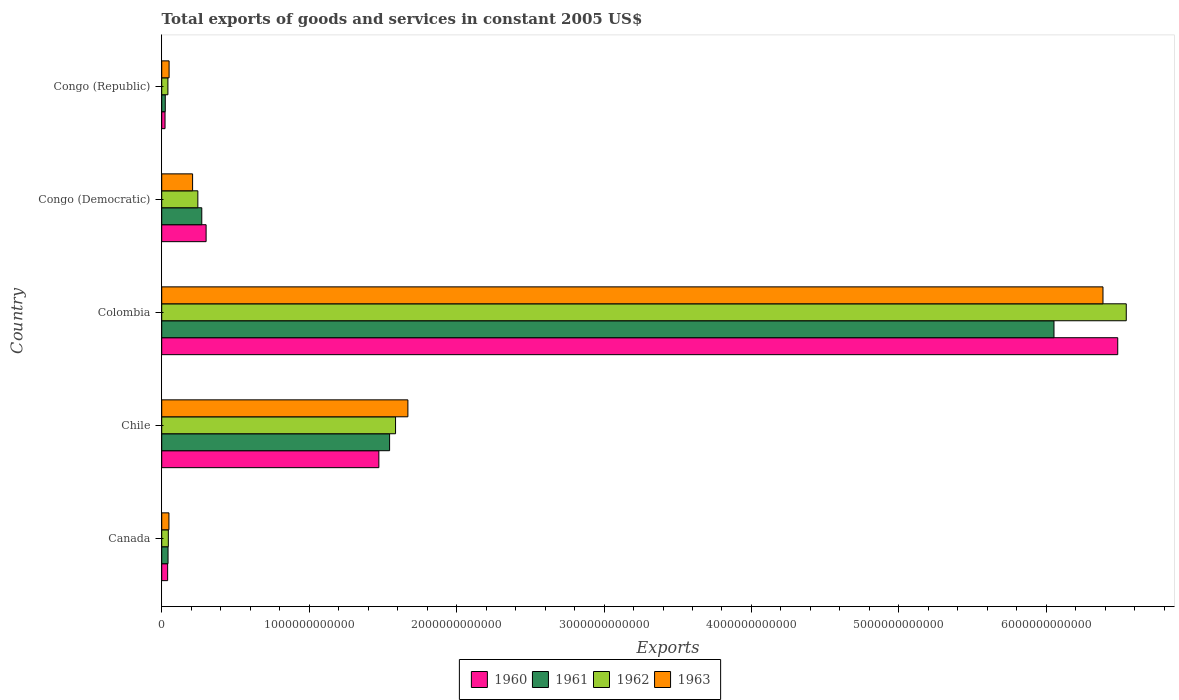Are the number of bars per tick equal to the number of legend labels?
Your answer should be compact. Yes. How many bars are there on the 3rd tick from the top?
Provide a short and direct response. 4. How many bars are there on the 4th tick from the bottom?
Keep it short and to the point. 4. What is the total exports of goods and services in 1963 in Chile?
Your answer should be very brief. 1.67e+12. Across all countries, what is the maximum total exports of goods and services in 1960?
Offer a terse response. 6.48e+12. Across all countries, what is the minimum total exports of goods and services in 1962?
Keep it short and to the point. 4.20e+1. In which country was the total exports of goods and services in 1963 maximum?
Ensure brevity in your answer.  Colombia. In which country was the total exports of goods and services in 1962 minimum?
Ensure brevity in your answer.  Congo (Republic). What is the total total exports of goods and services in 1963 in the graph?
Offer a very short reply. 8.36e+12. What is the difference between the total exports of goods and services in 1960 in Canada and that in Congo (Democratic)?
Give a very brief answer. -2.61e+11. What is the difference between the total exports of goods and services in 1960 in Congo (Democratic) and the total exports of goods and services in 1962 in Congo (Republic)?
Provide a short and direct response. 2.59e+11. What is the average total exports of goods and services in 1962 per country?
Provide a short and direct response. 1.69e+12. What is the difference between the total exports of goods and services in 1962 and total exports of goods and services in 1961 in Chile?
Provide a short and direct response. 4.03e+1. What is the ratio of the total exports of goods and services in 1961 in Colombia to that in Congo (Democratic)?
Give a very brief answer. 22.27. Is the difference between the total exports of goods and services in 1962 in Canada and Chile greater than the difference between the total exports of goods and services in 1961 in Canada and Chile?
Make the answer very short. No. What is the difference between the highest and the second highest total exports of goods and services in 1962?
Provide a short and direct response. 4.96e+12. What is the difference between the highest and the lowest total exports of goods and services in 1962?
Your answer should be very brief. 6.50e+12. Is the sum of the total exports of goods and services in 1960 in Canada and Congo (Democratic) greater than the maximum total exports of goods and services in 1962 across all countries?
Ensure brevity in your answer.  No. What does the 3rd bar from the top in Congo (Republic) represents?
Provide a short and direct response. 1961. How many bars are there?
Provide a short and direct response. 20. Are all the bars in the graph horizontal?
Provide a short and direct response. Yes. What is the difference between two consecutive major ticks on the X-axis?
Your answer should be compact. 1.00e+12. Are the values on the major ticks of X-axis written in scientific E-notation?
Offer a very short reply. No. Where does the legend appear in the graph?
Your response must be concise. Bottom center. How are the legend labels stacked?
Offer a very short reply. Horizontal. What is the title of the graph?
Ensure brevity in your answer.  Total exports of goods and services in constant 2005 US$. Does "1967" appear as one of the legend labels in the graph?
Your answer should be compact. No. What is the label or title of the X-axis?
Keep it short and to the point. Exports. What is the label or title of the Y-axis?
Your answer should be compact. Country. What is the Exports of 1960 in Canada?
Give a very brief answer. 4.02e+1. What is the Exports of 1961 in Canada?
Offer a very short reply. 4.29e+1. What is the Exports of 1962 in Canada?
Offer a very short reply. 4.49e+1. What is the Exports of 1963 in Canada?
Offer a very short reply. 4.91e+1. What is the Exports in 1960 in Chile?
Provide a succinct answer. 1.47e+12. What is the Exports in 1961 in Chile?
Keep it short and to the point. 1.55e+12. What is the Exports of 1962 in Chile?
Your answer should be very brief. 1.59e+12. What is the Exports in 1963 in Chile?
Give a very brief answer. 1.67e+12. What is the Exports of 1960 in Colombia?
Make the answer very short. 6.48e+12. What is the Exports of 1961 in Colombia?
Make the answer very short. 6.05e+12. What is the Exports of 1962 in Colombia?
Ensure brevity in your answer.  6.54e+12. What is the Exports of 1963 in Colombia?
Offer a very short reply. 6.38e+12. What is the Exports in 1960 in Congo (Democratic)?
Your answer should be very brief. 3.01e+11. What is the Exports of 1961 in Congo (Democratic)?
Your answer should be compact. 2.72e+11. What is the Exports in 1962 in Congo (Democratic)?
Make the answer very short. 2.45e+11. What is the Exports of 1963 in Congo (Democratic)?
Your response must be concise. 2.09e+11. What is the Exports in 1960 in Congo (Republic)?
Provide a short and direct response. 2.25e+1. What is the Exports in 1961 in Congo (Republic)?
Your answer should be compact. 2.42e+1. What is the Exports of 1962 in Congo (Republic)?
Offer a very short reply. 4.20e+1. What is the Exports in 1963 in Congo (Republic)?
Your answer should be compact. 5.01e+1. Across all countries, what is the maximum Exports in 1960?
Your answer should be very brief. 6.48e+12. Across all countries, what is the maximum Exports in 1961?
Offer a terse response. 6.05e+12. Across all countries, what is the maximum Exports of 1962?
Keep it short and to the point. 6.54e+12. Across all countries, what is the maximum Exports of 1963?
Keep it short and to the point. 6.38e+12. Across all countries, what is the minimum Exports in 1960?
Provide a succinct answer. 2.25e+1. Across all countries, what is the minimum Exports of 1961?
Give a very brief answer. 2.42e+1. Across all countries, what is the minimum Exports of 1962?
Your answer should be compact. 4.20e+1. Across all countries, what is the minimum Exports of 1963?
Offer a very short reply. 4.91e+1. What is the total Exports in 1960 in the graph?
Make the answer very short. 8.32e+12. What is the total Exports of 1961 in the graph?
Your answer should be compact. 7.94e+12. What is the total Exports of 1962 in the graph?
Make the answer very short. 8.46e+12. What is the total Exports of 1963 in the graph?
Provide a succinct answer. 8.36e+12. What is the difference between the Exports of 1960 in Canada and that in Chile?
Your response must be concise. -1.43e+12. What is the difference between the Exports of 1961 in Canada and that in Chile?
Provide a short and direct response. -1.50e+12. What is the difference between the Exports in 1962 in Canada and that in Chile?
Your answer should be very brief. -1.54e+12. What is the difference between the Exports in 1963 in Canada and that in Chile?
Make the answer very short. -1.62e+12. What is the difference between the Exports of 1960 in Canada and that in Colombia?
Your answer should be very brief. -6.44e+12. What is the difference between the Exports in 1961 in Canada and that in Colombia?
Provide a succinct answer. -6.01e+12. What is the difference between the Exports of 1962 in Canada and that in Colombia?
Offer a terse response. -6.50e+12. What is the difference between the Exports of 1963 in Canada and that in Colombia?
Offer a terse response. -6.34e+12. What is the difference between the Exports of 1960 in Canada and that in Congo (Democratic)?
Your answer should be very brief. -2.61e+11. What is the difference between the Exports of 1961 in Canada and that in Congo (Democratic)?
Offer a terse response. -2.29e+11. What is the difference between the Exports in 1962 in Canada and that in Congo (Democratic)?
Ensure brevity in your answer.  -2.00e+11. What is the difference between the Exports of 1963 in Canada and that in Congo (Democratic)?
Provide a short and direct response. -1.60e+11. What is the difference between the Exports in 1960 in Canada and that in Congo (Republic)?
Keep it short and to the point. 1.77e+1. What is the difference between the Exports of 1961 in Canada and that in Congo (Republic)?
Provide a succinct answer. 1.87e+1. What is the difference between the Exports of 1962 in Canada and that in Congo (Republic)?
Keep it short and to the point. 2.86e+09. What is the difference between the Exports in 1963 in Canada and that in Congo (Republic)?
Your answer should be compact. -1.07e+09. What is the difference between the Exports in 1960 in Chile and that in Colombia?
Provide a short and direct response. -5.01e+12. What is the difference between the Exports in 1961 in Chile and that in Colombia?
Ensure brevity in your answer.  -4.51e+12. What is the difference between the Exports in 1962 in Chile and that in Colombia?
Provide a short and direct response. -4.96e+12. What is the difference between the Exports in 1963 in Chile and that in Colombia?
Your response must be concise. -4.71e+12. What is the difference between the Exports of 1960 in Chile and that in Congo (Democratic)?
Keep it short and to the point. 1.17e+12. What is the difference between the Exports in 1961 in Chile and that in Congo (Democratic)?
Offer a terse response. 1.27e+12. What is the difference between the Exports in 1962 in Chile and that in Congo (Democratic)?
Offer a terse response. 1.34e+12. What is the difference between the Exports in 1963 in Chile and that in Congo (Democratic)?
Make the answer very short. 1.46e+12. What is the difference between the Exports in 1960 in Chile and that in Congo (Republic)?
Provide a short and direct response. 1.45e+12. What is the difference between the Exports of 1961 in Chile and that in Congo (Republic)?
Provide a short and direct response. 1.52e+12. What is the difference between the Exports of 1962 in Chile and that in Congo (Republic)?
Keep it short and to the point. 1.54e+12. What is the difference between the Exports in 1963 in Chile and that in Congo (Republic)?
Offer a very short reply. 1.62e+12. What is the difference between the Exports of 1960 in Colombia and that in Congo (Democratic)?
Your response must be concise. 6.18e+12. What is the difference between the Exports in 1961 in Colombia and that in Congo (Democratic)?
Offer a terse response. 5.78e+12. What is the difference between the Exports in 1962 in Colombia and that in Congo (Democratic)?
Your response must be concise. 6.30e+12. What is the difference between the Exports of 1963 in Colombia and that in Congo (Democratic)?
Offer a very short reply. 6.17e+12. What is the difference between the Exports of 1960 in Colombia and that in Congo (Republic)?
Offer a terse response. 6.46e+12. What is the difference between the Exports of 1961 in Colombia and that in Congo (Republic)?
Offer a very short reply. 6.03e+12. What is the difference between the Exports in 1962 in Colombia and that in Congo (Republic)?
Ensure brevity in your answer.  6.50e+12. What is the difference between the Exports of 1963 in Colombia and that in Congo (Republic)?
Your answer should be very brief. 6.33e+12. What is the difference between the Exports of 1960 in Congo (Democratic) and that in Congo (Republic)?
Your answer should be compact. 2.79e+11. What is the difference between the Exports of 1961 in Congo (Democratic) and that in Congo (Republic)?
Offer a very short reply. 2.48e+11. What is the difference between the Exports of 1962 in Congo (Democratic) and that in Congo (Republic)?
Provide a short and direct response. 2.03e+11. What is the difference between the Exports of 1963 in Congo (Democratic) and that in Congo (Republic)?
Your response must be concise. 1.59e+11. What is the difference between the Exports of 1960 in Canada and the Exports of 1961 in Chile?
Offer a very short reply. -1.51e+12. What is the difference between the Exports in 1960 in Canada and the Exports in 1962 in Chile?
Make the answer very short. -1.55e+12. What is the difference between the Exports in 1960 in Canada and the Exports in 1963 in Chile?
Your response must be concise. -1.63e+12. What is the difference between the Exports of 1961 in Canada and the Exports of 1962 in Chile?
Your answer should be very brief. -1.54e+12. What is the difference between the Exports in 1961 in Canada and the Exports in 1963 in Chile?
Offer a very short reply. -1.63e+12. What is the difference between the Exports in 1962 in Canada and the Exports in 1963 in Chile?
Provide a short and direct response. -1.62e+12. What is the difference between the Exports of 1960 in Canada and the Exports of 1961 in Colombia?
Make the answer very short. -6.01e+12. What is the difference between the Exports of 1960 in Canada and the Exports of 1962 in Colombia?
Ensure brevity in your answer.  -6.50e+12. What is the difference between the Exports in 1960 in Canada and the Exports in 1963 in Colombia?
Ensure brevity in your answer.  -6.34e+12. What is the difference between the Exports of 1961 in Canada and the Exports of 1962 in Colombia?
Offer a very short reply. -6.50e+12. What is the difference between the Exports in 1961 in Canada and the Exports in 1963 in Colombia?
Ensure brevity in your answer.  -6.34e+12. What is the difference between the Exports in 1962 in Canada and the Exports in 1963 in Colombia?
Keep it short and to the point. -6.34e+12. What is the difference between the Exports in 1960 in Canada and the Exports in 1961 in Congo (Democratic)?
Give a very brief answer. -2.32e+11. What is the difference between the Exports in 1960 in Canada and the Exports in 1962 in Congo (Democratic)?
Offer a very short reply. -2.05e+11. What is the difference between the Exports in 1960 in Canada and the Exports in 1963 in Congo (Democratic)?
Give a very brief answer. -1.69e+11. What is the difference between the Exports in 1961 in Canada and the Exports in 1962 in Congo (Democratic)?
Keep it short and to the point. -2.02e+11. What is the difference between the Exports of 1961 in Canada and the Exports of 1963 in Congo (Democratic)?
Keep it short and to the point. -1.67e+11. What is the difference between the Exports of 1962 in Canada and the Exports of 1963 in Congo (Democratic)?
Make the answer very short. -1.65e+11. What is the difference between the Exports in 1960 in Canada and the Exports in 1961 in Congo (Republic)?
Offer a very short reply. 1.60e+1. What is the difference between the Exports in 1960 in Canada and the Exports in 1962 in Congo (Republic)?
Offer a very short reply. -1.85e+09. What is the difference between the Exports of 1960 in Canada and the Exports of 1963 in Congo (Republic)?
Keep it short and to the point. -9.92e+09. What is the difference between the Exports in 1961 in Canada and the Exports in 1962 in Congo (Republic)?
Provide a succinct answer. 8.81e+08. What is the difference between the Exports in 1961 in Canada and the Exports in 1963 in Congo (Republic)?
Provide a succinct answer. -7.19e+09. What is the difference between the Exports of 1962 in Canada and the Exports of 1963 in Congo (Republic)?
Your response must be concise. -5.21e+09. What is the difference between the Exports in 1960 in Chile and the Exports in 1961 in Colombia?
Your response must be concise. -4.58e+12. What is the difference between the Exports of 1960 in Chile and the Exports of 1962 in Colombia?
Give a very brief answer. -5.07e+12. What is the difference between the Exports in 1960 in Chile and the Exports in 1963 in Colombia?
Your answer should be compact. -4.91e+12. What is the difference between the Exports in 1961 in Chile and the Exports in 1962 in Colombia?
Provide a succinct answer. -5.00e+12. What is the difference between the Exports in 1961 in Chile and the Exports in 1963 in Colombia?
Your response must be concise. -4.84e+12. What is the difference between the Exports of 1962 in Chile and the Exports of 1963 in Colombia?
Provide a short and direct response. -4.80e+12. What is the difference between the Exports of 1960 in Chile and the Exports of 1961 in Congo (Democratic)?
Your answer should be very brief. 1.20e+12. What is the difference between the Exports of 1960 in Chile and the Exports of 1962 in Congo (Democratic)?
Your response must be concise. 1.23e+12. What is the difference between the Exports in 1960 in Chile and the Exports in 1963 in Congo (Democratic)?
Offer a terse response. 1.26e+12. What is the difference between the Exports in 1961 in Chile and the Exports in 1962 in Congo (Democratic)?
Ensure brevity in your answer.  1.30e+12. What is the difference between the Exports in 1961 in Chile and the Exports in 1963 in Congo (Democratic)?
Ensure brevity in your answer.  1.34e+12. What is the difference between the Exports in 1962 in Chile and the Exports in 1963 in Congo (Democratic)?
Offer a very short reply. 1.38e+12. What is the difference between the Exports in 1960 in Chile and the Exports in 1961 in Congo (Republic)?
Ensure brevity in your answer.  1.45e+12. What is the difference between the Exports of 1960 in Chile and the Exports of 1962 in Congo (Republic)?
Provide a short and direct response. 1.43e+12. What is the difference between the Exports of 1960 in Chile and the Exports of 1963 in Congo (Republic)?
Your answer should be very brief. 1.42e+12. What is the difference between the Exports of 1961 in Chile and the Exports of 1962 in Congo (Republic)?
Provide a short and direct response. 1.50e+12. What is the difference between the Exports of 1961 in Chile and the Exports of 1963 in Congo (Republic)?
Offer a terse response. 1.50e+12. What is the difference between the Exports in 1962 in Chile and the Exports in 1963 in Congo (Republic)?
Offer a terse response. 1.54e+12. What is the difference between the Exports in 1960 in Colombia and the Exports in 1961 in Congo (Democratic)?
Offer a terse response. 6.21e+12. What is the difference between the Exports in 1960 in Colombia and the Exports in 1962 in Congo (Democratic)?
Offer a terse response. 6.24e+12. What is the difference between the Exports of 1960 in Colombia and the Exports of 1963 in Congo (Democratic)?
Ensure brevity in your answer.  6.27e+12. What is the difference between the Exports of 1961 in Colombia and the Exports of 1962 in Congo (Democratic)?
Give a very brief answer. 5.81e+12. What is the difference between the Exports of 1961 in Colombia and the Exports of 1963 in Congo (Democratic)?
Give a very brief answer. 5.84e+12. What is the difference between the Exports of 1962 in Colombia and the Exports of 1963 in Congo (Democratic)?
Your answer should be very brief. 6.33e+12. What is the difference between the Exports of 1960 in Colombia and the Exports of 1961 in Congo (Republic)?
Your answer should be compact. 6.46e+12. What is the difference between the Exports in 1960 in Colombia and the Exports in 1962 in Congo (Republic)?
Provide a succinct answer. 6.44e+12. What is the difference between the Exports of 1960 in Colombia and the Exports of 1963 in Congo (Republic)?
Make the answer very short. 6.43e+12. What is the difference between the Exports in 1961 in Colombia and the Exports in 1962 in Congo (Republic)?
Offer a very short reply. 6.01e+12. What is the difference between the Exports in 1961 in Colombia and the Exports in 1963 in Congo (Republic)?
Give a very brief answer. 6.00e+12. What is the difference between the Exports of 1962 in Colombia and the Exports of 1963 in Congo (Republic)?
Keep it short and to the point. 6.49e+12. What is the difference between the Exports in 1960 in Congo (Democratic) and the Exports in 1961 in Congo (Republic)?
Provide a short and direct response. 2.77e+11. What is the difference between the Exports of 1960 in Congo (Democratic) and the Exports of 1962 in Congo (Republic)?
Keep it short and to the point. 2.59e+11. What is the difference between the Exports of 1960 in Congo (Democratic) and the Exports of 1963 in Congo (Republic)?
Keep it short and to the point. 2.51e+11. What is the difference between the Exports of 1961 in Congo (Democratic) and the Exports of 1962 in Congo (Republic)?
Provide a succinct answer. 2.30e+11. What is the difference between the Exports of 1961 in Congo (Democratic) and the Exports of 1963 in Congo (Republic)?
Your answer should be very brief. 2.22e+11. What is the difference between the Exports in 1962 in Congo (Democratic) and the Exports in 1963 in Congo (Republic)?
Make the answer very short. 1.95e+11. What is the average Exports in 1960 per country?
Your response must be concise. 1.66e+12. What is the average Exports in 1961 per country?
Make the answer very short. 1.59e+12. What is the average Exports in 1962 per country?
Ensure brevity in your answer.  1.69e+12. What is the average Exports of 1963 per country?
Your answer should be compact. 1.67e+12. What is the difference between the Exports of 1960 and Exports of 1961 in Canada?
Your answer should be compact. -2.73e+09. What is the difference between the Exports in 1960 and Exports in 1962 in Canada?
Keep it short and to the point. -4.72e+09. What is the difference between the Exports in 1960 and Exports in 1963 in Canada?
Your answer should be compact. -8.86e+09. What is the difference between the Exports of 1961 and Exports of 1962 in Canada?
Ensure brevity in your answer.  -1.98e+09. What is the difference between the Exports in 1961 and Exports in 1963 in Canada?
Your answer should be compact. -6.12e+09. What is the difference between the Exports of 1962 and Exports of 1963 in Canada?
Ensure brevity in your answer.  -4.14e+09. What is the difference between the Exports of 1960 and Exports of 1961 in Chile?
Provide a succinct answer. -7.28e+1. What is the difference between the Exports of 1960 and Exports of 1962 in Chile?
Your answer should be very brief. -1.13e+11. What is the difference between the Exports in 1960 and Exports in 1963 in Chile?
Make the answer very short. -1.97e+11. What is the difference between the Exports of 1961 and Exports of 1962 in Chile?
Keep it short and to the point. -4.03e+1. What is the difference between the Exports of 1961 and Exports of 1963 in Chile?
Keep it short and to the point. -1.24e+11. What is the difference between the Exports of 1962 and Exports of 1963 in Chile?
Offer a terse response. -8.37e+1. What is the difference between the Exports of 1960 and Exports of 1961 in Colombia?
Provide a succinct answer. 4.32e+11. What is the difference between the Exports in 1960 and Exports in 1962 in Colombia?
Your response must be concise. -5.79e+1. What is the difference between the Exports in 1960 and Exports in 1963 in Colombia?
Keep it short and to the point. 1.00e+11. What is the difference between the Exports in 1961 and Exports in 1962 in Colombia?
Your answer should be very brief. -4.90e+11. What is the difference between the Exports of 1961 and Exports of 1963 in Colombia?
Your response must be concise. -3.32e+11. What is the difference between the Exports in 1962 and Exports in 1963 in Colombia?
Offer a very short reply. 1.58e+11. What is the difference between the Exports of 1960 and Exports of 1961 in Congo (Democratic)?
Your answer should be very brief. 2.94e+1. What is the difference between the Exports of 1960 and Exports of 1962 in Congo (Democratic)?
Your response must be concise. 5.61e+1. What is the difference between the Exports in 1960 and Exports in 1963 in Congo (Democratic)?
Offer a very short reply. 9.17e+1. What is the difference between the Exports of 1961 and Exports of 1962 in Congo (Democratic)?
Keep it short and to the point. 2.67e+1. What is the difference between the Exports of 1961 and Exports of 1963 in Congo (Democratic)?
Give a very brief answer. 6.23e+1. What is the difference between the Exports in 1962 and Exports in 1963 in Congo (Democratic)?
Offer a very short reply. 3.56e+1. What is the difference between the Exports of 1960 and Exports of 1961 in Congo (Republic)?
Your answer should be very brief. -1.69e+09. What is the difference between the Exports in 1960 and Exports in 1962 in Congo (Republic)?
Offer a very short reply. -1.95e+1. What is the difference between the Exports in 1960 and Exports in 1963 in Congo (Republic)?
Ensure brevity in your answer.  -2.76e+1. What is the difference between the Exports of 1961 and Exports of 1962 in Congo (Republic)?
Offer a very short reply. -1.78e+1. What is the difference between the Exports of 1961 and Exports of 1963 in Congo (Republic)?
Make the answer very short. -2.59e+1. What is the difference between the Exports of 1962 and Exports of 1963 in Congo (Republic)?
Offer a terse response. -8.07e+09. What is the ratio of the Exports in 1960 in Canada to that in Chile?
Provide a short and direct response. 0.03. What is the ratio of the Exports in 1961 in Canada to that in Chile?
Keep it short and to the point. 0.03. What is the ratio of the Exports of 1962 in Canada to that in Chile?
Provide a succinct answer. 0.03. What is the ratio of the Exports in 1963 in Canada to that in Chile?
Keep it short and to the point. 0.03. What is the ratio of the Exports in 1960 in Canada to that in Colombia?
Ensure brevity in your answer.  0.01. What is the ratio of the Exports of 1961 in Canada to that in Colombia?
Provide a succinct answer. 0.01. What is the ratio of the Exports of 1962 in Canada to that in Colombia?
Your answer should be compact. 0.01. What is the ratio of the Exports in 1963 in Canada to that in Colombia?
Give a very brief answer. 0.01. What is the ratio of the Exports in 1960 in Canada to that in Congo (Democratic)?
Provide a short and direct response. 0.13. What is the ratio of the Exports in 1961 in Canada to that in Congo (Democratic)?
Give a very brief answer. 0.16. What is the ratio of the Exports of 1962 in Canada to that in Congo (Democratic)?
Ensure brevity in your answer.  0.18. What is the ratio of the Exports in 1963 in Canada to that in Congo (Democratic)?
Ensure brevity in your answer.  0.23. What is the ratio of the Exports of 1960 in Canada to that in Congo (Republic)?
Offer a terse response. 1.78. What is the ratio of the Exports of 1961 in Canada to that in Congo (Republic)?
Your response must be concise. 1.77. What is the ratio of the Exports in 1962 in Canada to that in Congo (Republic)?
Make the answer very short. 1.07. What is the ratio of the Exports of 1963 in Canada to that in Congo (Republic)?
Offer a very short reply. 0.98. What is the ratio of the Exports of 1960 in Chile to that in Colombia?
Your answer should be compact. 0.23. What is the ratio of the Exports of 1961 in Chile to that in Colombia?
Your answer should be very brief. 0.26. What is the ratio of the Exports of 1962 in Chile to that in Colombia?
Offer a very short reply. 0.24. What is the ratio of the Exports of 1963 in Chile to that in Colombia?
Give a very brief answer. 0.26. What is the ratio of the Exports of 1960 in Chile to that in Congo (Democratic)?
Offer a very short reply. 4.89. What is the ratio of the Exports of 1961 in Chile to that in Congo (Democratic)?
Provide a short and direct response. 5.69. What is the ratio of the Exports in 1962 in Chile to that in Congo (Democratic)?
Your answer should be compact. 6.47. What is the ratio of the Exports of 1963 in Chile to that in Congo (Democratic)?
Provide a short and direct response. 7.97. What is the ratio of the Exports of 1960 in Chile to that in Congo (Republic)?
Offer a very short reply. 65.38. What is the ratio of the Exports of 1961 in Chile to that in Congo (Republic)?
Keep it short and to the point. 63.82. What is the ratio of the Exports of 1962 in Chile to that in Congo (Republic)?
Your answer should be very brief. 37.72. What is the ratio of the Exports in 1963 in Chile to that in Congo (Republic)?
Your answer should be very brief. 33.31. What is the ratio of the Exports of 1960 in Colombia to that in Congo (Democratic)?
Offer a terse response. 21.53. What is the ratio of the Exports of 1961 in Colombia to that in Congo (Democratic)?
Your response must be concise. 22.27. What is the ratio of the Exports of 1962 in Colombia to that in Congo (Democratic)?
Make the answer very short. 26.7. What is the ratio of the Exports of 1963 in Colombia to that in Congo (Democratic)?
Your answer should be very brief. 30.48. What is the ratio of the Exports in 1960 in Colombia to that in Congo (Republic)?
Give a very brief answer. 287.84. What is the ratio of the Exports in 1961 in Colombia to that in Congo (Republic)?
Provide a short and direct response. 249.91. What is the ratio of the Exports in 1962 in Colombia to that in Congo (Republic)?
Offer a terse response. 155.58. What is the ratio of the Exports in 1963 in Colombia to that in Congo (Republic)?
Make the answer very short. 127.37. What is the ratio of the Exports in 1960 in Congo (Democratic) to that in Congo (Republic)?
Your answer should be very brief. 13.37. What is the ratio of the Exports of 1961 in Congo (Democratic) to that in Congo (Republic)?
Keep it short and to the point. 11.22. What is the ratio of the Exports of 1962 in Congo (Democratic) to that in Congo (Republic)?
Offer a very short reply. 5.83. What is the ratio of the Exports in 1963 in Congo (Democratic) to that in Congo (Republic)?
Give a very brief answer. 4.18. What is the difference between the highest and the second highest Exports in 1960?
Offer a terse response. 5.01e+12. What is the difference between the highest and the second highest Exports in 1961?
Give a very brief answer. 4.51e+12. What is the difference between the highest and the second highest Exports of 1962?
Provide a short and direct response. 4.96e+12. What is the difference between the highest and the second highest Exports in 1963?
Provide a succinct answer. 4.71e+12. What is the difference between the highest and the lowest Exports of 1960?
Give a very brief answer. 6.46e+12. What is the difference between the highest and the lowest Exports in 1961?
Make the answer very short. 6.03e+12. What is the difference between the highest and the lowest Exports of 1962?
Keep it short and to the point. 6.50e+12. What is the difference between the highest and the lowest Exports in 1963?
Your answer should be compact. 6.34e+12. 